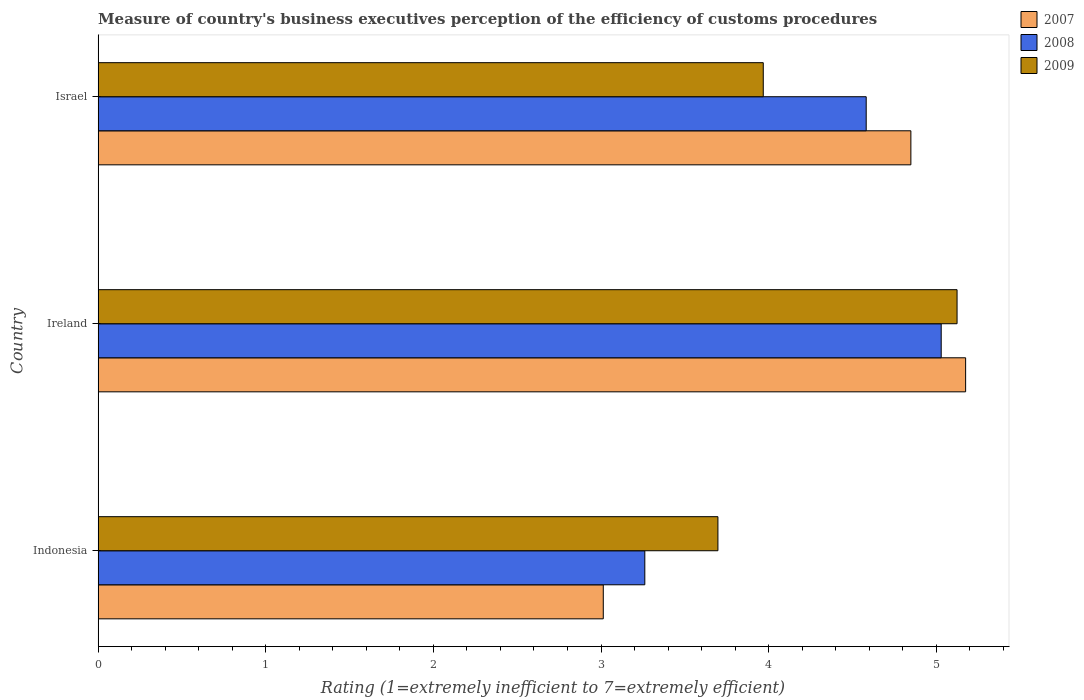How many groups of bars are there?
Your answer should be very brief. 3. How many bars are there on the 3rd tick from the top?
Ensure brevity in your answer.  3. How many bars are there on the 3rd tick from the bottom?
Your response must be concise. 3. What is the rating of the efficiency of customs procedure in 2007 in Indonesia?
Provide a succinct answer. 3.01. Across all countries, what is the maximum rating of the efficiency of customs procedure in 2007?
Give a very brief answer. 5.17. Across all countries, what is the minimum rating of the efficiency of customs procedure in 2009?
Provide a succinct answer. 3.7. In which country was the rating of the efficiency of customs procedure in 2009 maximum?
Provide a short and direct response. Ireland. In which country was the rating of the efficiency of customs procedure in 2007 minimum?
Make the answer very short. Indonesia. What is the total rating of the efficiency of customs procedure in 2007 in the graph?
Ensure brevity in your answer.  13.04. What is the difference between the rating of the efficiency of customs procedure in 2007 in Indonesia and that in Ireland?
Your answer should be very brief. -2.16. What is the difference between the rating of the efficiency of customs procedure in 2009 in Israel and the rating of the efficiency of customs procedure in 2008 in Indonesia?
Your response must be concise. 0.71. What is the average rating of the efficiency of customs procedure in 2009 per country?
Give a very brief answer. 4.26. What is the difference between the rating of the efficiency of customs procedure in 2007 and rating of the efficiency of customs procedure in 2008 in Ireland?
Your answer should be compact. 0.15. In how many countries, is the rating of the efficiency of customs procedure in 2009 greater than 2.4 ?
Offer a terse response. 3. What is the ratio of the rating of the efficiency of customs procedure in 2007 in Indonesia to that in Israel?
Offer a terse response. 0.62. Is the rating of the efficiency of customs procedure in 2008 in Indonesia less than that in Israel?
Keep it short and to the point. Yes. Is the difference between the rating of the efficiency of customs procedure in 2007 in Ireland and Israel greater than the difference between the rating of the efficiency of customs procedure in 2008 in Ireland and Israel?
Give a very brief answer. No. What is the difference between the highest and the second highest rating of the efficiency of customs procedure in 2007?
Provide a succinct answer. 0.33. What is the difference between the highest and the lowest rating of the efficiency of customs procedure in 2007?
Offer a very short reply. 2.16. In how many countries, is the rating of the efficiency of customs procedure in 2007 greater than the average rating of the efficiency of customs procedure in 2007 taken over all countries?
Your response must be concise. 2. Is the sum of the rating of the efficiency of customs procedure in 2009 in Indonesia and Israel greater than the maximum rating of the efficiency of customs procedure in 2007 across all countries?
Your answer should be compact. Yes. What does the 2nd bar from the top in Indonesia represents?
Make the answer very short. 2008. What does the 2nd bar from the bottom in Indonesia represents?
Give a very brief answer. 2008. Are all the bars in the graph horizontal?
Ensure brevity in your answer.  Yes. How many countries are there in the graph?
Provide a succinct answer. 3. How many legend labels are there?
Give a very brief answer. 3. What is the title of the graph?
Your response must be concise. Measure of country's business executives perception of the efficiency of customs procedures. Does "1971" appear as one of the legend labels in the graph?
Ensure brevity in your answer.  No. What is the label or title of the X-axis?
Offer a very short reply. Rating (1=extremely inefficient to 7=extremely efficient). What is the Rating (1=extremely inefficient to 7=extremely efficient) in 2007 in Indonesia?
Keep it short and to the point. 3.01. What is the Rating (1=extremely inefficient to 7=extremely efficient) of 2008 in Indonesia?
Your answer should be very brief. 3.26. What is the Rating (1=extremely inefficient to 7=extremely efficient) in 2009 in Indonesia?
Your response must be concise. 3.7. What is the Rating (1=extremely inefficient to 7=extremely efficient) in 2007 in Ireland?
Your response must be concise. 5.17. What is the Rating (1=extremely inefficient to 7=extremely efficient) in 2008 in Ireland?
Offer a very short reply. 5.03. What is the Rating (1=extremely inefficient to 7=extremely efficient) of 2009 in Ireland?
Make the answer very short. 5.12. What is the Rating (1=extremely inefficient to 7=extremely efficient) in 2007 in Israel?
Your response must be concise. 4.85. What is the Rating (1=extremely inefficient to 7=extremely efficient) of 2008 in Israel?
Your answer should be very brief. 4.58. What is the Rating (1=extremely inefficient to 7=extremely efficient) in 2009 in Israel?
Ensure brevity in your answer.  3.97. Across all countries, what is the maximum Rating (1=extremely inefficient to 7=extremely efficient) in 2007?
Your response must be concise. 5.17. Across all countries, what is the maximum Rating (1=extremely inefficient to 7=extremely efficient) of 2008?
Give a very brief answer. 5.03. Across all countries, what is the maximum Rating (1=extremely inefficient to 7=extremely efficient) in 2009?
Your answer should be very brief. 5.12. Across all countries, what is the minimum Rating (1=extremely inefficient to 7=extremely efficient) of 2007?
Your answer should be very brief. 3.01. Across all countries, what is the minimum Rating (1=extremely inefficient to 7=extremely efficient) in 2008?
Make the answer very short. 3.26. Across all countries, what is the minimum Rating (1=extremely inefficient to 7=extremely efficient) in 2009?
Offer a very short reply. 3.7. What is the total Rating (1=extremely inefficient to 7=extremely efficient) of 2007 in the graph?
Ensure brevity in your answer.  13.04. What is the total Rating (1=extremely inefficient to 7=extremely efficient) of 2008 in the graph?
Give a very brief answer. 12.87. What is the total Rating (1=extremely inefficient to 7=extremely efficient) of 2009 in the graph?
Your answer should be compact. 12.79. What is the difference between the Rating (1=extremely inefficient to 7=extremely efficient) of 2007 in Indonesia and that in Ireland?
Ensure brevity in your answer.  -2.16. What is the difference between the Rating (1=extremely inefficient to 7=extremely efficient) of 2008 in Indonesia and that in Ireland?
Offer a very short reply. -1.77. What is the difference between the Rating (1=extremely inefficient to 7=extremely efficient) of 2009 in Indonesia and that in Ireland?
Your answer should be very brief. -1.43. What is the difference between the Rating (1=extremely inefficient to 7=extremely efficient) of 2007 in Indonesia and that in Israel?
Provide a short and direct response. -1.83. What is the difference between the Rating (1=extremely inefficient to 7=extremely efficient) of 2008 in Indonesia and that in Israel?
Give a very brief answer. -1.32. What is the difference between the Rating (1=extremely inefficient to 7=extremely efficient) in 2009 in Indonesia and that in Israel?
Your answer should be compact. -0.27. What is the difference between the Rating (1=extremely inefficient to 7=extremely efficient) in 2007 in Ireland and that in Israel?
Make the answer very short. 0.33. What is the difference between the Rating (1=extremely inefficient to 7=extremely efficient) of 2008 in Ireland and that in Israel?
Ensure brevity in your answer.  0.45. What is the difference between the Rating (1=extremely inefficient to 7=extremely efficient) in 2009 in Ireland and that in Israel?
Offer a very short reply. 1.16. What is the difference between the Rating (1=extremely inefficient to 7=extremely efficient) in 2007 in Indonesia and the Rating (1=extremely inefficient to 7=extremely efficient) in 2008 in Ireland?
Your answer should be compact. -2.02. What is the difference between the Rating (1=extremely inefficient to 7=extremely efficient) in 2007 in Indonesia and the Rating (1=extremely inefficient to 7=extremely efficient) in 2009 in Ireland?
Ensure brevity in your answer.  -2.11. What is the difference between the Rating (1=extremely inefficient to 7=extremely efficient) in 2008 in Indonesia and the Rating (1=extremely inefficient to 7=extremely efficient) in 2009 in Ireland?
Your answer should be very brief. -1.86. What is the difference between the Rating (1=extremely inefficient to 7=extremely efficient) in 2007 in Indonesia and the Rating (1=extremely inefficient to 7=extremely efficient) in 2008 in Israel?
Your answer should be very brief. -1.57. What is the difference between the Rating (1=extremely inefficient to 7=extremely efficient) of 2007 in Indonesia and the Rating (1=extremely inefficient to 7=extremely efficient) of 2009 in Israel?
Provide a succinct answer. -0.95. What is the difference between the Rating (1=extremely inefficient to 7=extremely efficient) of 2008 in Indonesia and the Rating (1=extremely inefficient to 7=extremely efficient) of 2009 in Israel?
Make the answer very short. -0.71. What is the difference between the Rating (1=extremely inefficient to 7=extremely efficient) in 2007 in Ireland and the Rating (1=extremely inefficient to 7=extremely efficient) in 2008 in Israel?
Your answer should be compact. 0.59. What is the difference between the Rating (1=extremely inefficient to 7=extremely efficient) in 2007 in Ireland and the Rating (1=extremely inefficient to 7=extremely efficient) in 2009 in Israel?
Ensure brevity in your answer.  1.21. What is the difference between the Rating (1=extremely inefficient to 7=extremely efficient) of 2008 in Ireland and the Rating (1=extremely inefficient to 7=extremely efficient) of 2009 in Israel?
Provide a succinct answer. 1.06. What is the average Rating (1=extremely inefficient to 7=extremely efficient) of 2007 per country?
Ensure brevity in your answer.  4.35. What is the average Rating (1=extremely inefficient to 7=extremely efficient) in 2008 per country?
Keep it short and to the point. 4.29. What is the average Rating (1=extremely inefficient to 7=extremely efficient) in 2009 per country?
Your answer should be very brief. 4.26. What is the difference between the Rating (1=extremely inefficient to 7=extremely efficient) of 2007 and Rating (1=extremely inefficient to 7=extremely efficient) of 2008 in Indonesia?
Offer a terse response. -0.25. What is the difference between the Rating (1=extremely inefficient to 7=extremely efficient) of 2007 and Rating (1=extremely inefficient to 7=extremely efficient) of 2009 in Indonesia?
Make the answer very short. -0.68. What is the difference between the Rating (1=extremely inefficient to 7=extremely efficient) of 2008 and Rating (1=extremely inefficient to 7=extremely efficient) of 2009 in Indonesia?
Offer a very short reply. -0.44. What is the difference between the Rating (1=extremely inefficient to 7=extremely efficient) of 2007 and Rating (1=extremely inefficient to 7=extremely efficient) of 2008 in Ireland?
Make the answer very short. 0.15. What is the difference between the Rating (1=extremely inefficient to 7=extremely efficient) of 2007 and Rating (1=extremely inefficient to 7=extremely efficient) of 2009 in Ireland?
Give a very brief answer. 0.05. What is the difference between the Rating (1=extremely inefficient to 7=extremely efficient) of 2008 and Rating (1=extremely inefficient to 7=extremely efficient) of 2009 in Ireland?
Your response must be concise. -0.09. What is the difference between the Rating (1=extremely inefficient to 7=extremely efficient) in 2007 and Rating (1=extremely inefficient to 7=extremely efficient) in 2008 in Israel?
Your answer should be very brief. 0.27. What is the difference between the Rating (1=extremely inefficient to 7=extremely efficient) in 2007 and Rating (1=extremely inefficient to 7=extremely efficient) in 2009 in Israel?
Give a very brief answer. 0.88. What is the difference between the Rating (1=extremely inefficient to 7=extremely efficient) in 2008 and Rating (1=extremely inefficient to 7=extremely efficient) in 2009 in Israel?
Make the answer very short. 0.61. What is the ratio of the Rating (1=extremely inefficient to 7=extremely efficient) in 2007 in Indonesia to that in Ireland?
Offer a terse response. 0.58. What is the ratio of the Rating (1=extremely inefficient to 7=extremely efficient) of 2008 in Indonesia to that in Ireland?
Provide a succinct answer. 0.65. What is the ratio of the Rating (1=extremely inefficient to 7=extremely efficient) in 2009 in Indonesia to that in Ireland?
Make the answer very short. 0.72. What is the ratio of the Rating (1=extremely inefficient to 7=extremely efficient) in 2007 in Indonesia to that in Israel?
Make the answer very short. 0.62. What is the ratio of the Rating (1=extremely inefficient to 7=extremely efficient) in 2008 in Indonesia to that in Israel?
Make the answer very short. 0.71. What is the ratio of the Rating (1=extremely inefficient to 7=extremely efficient) of 2009 in Indonesia to that in Israel?
Your answer should be very brief. 0.93. What is the ratio of the Rating (1=extremely inefficient to 7=extremely efficient) in 2007 in Ireland to that in Israel?
Ensure brevity in your answer.  1.07. What is the ratio of the Rating (1=extremely inefficient to 7=extremely efficient) of 2008 in Ireland to that in Israel?
Your response must be concise. 1.1. What is the ratio of the Rating (1=extremely inefficient to 7=extremely efficient) in 2009 in Ireland to that in Israel?
Make the answer very short. 1.29. What is the difference between the highest and the second highest Rating (1=extremely inefficient to 7=extremely efficient) in 2007?
Provide a short and direct response. 0.33. What is the difference between the highest and the second highest Rating (1=extremely inefficient to 7=extremely efficient) of 2008?
Provide a succinct answer. 0.45. What is the difference between the highest and the second highest Rating (1=extremely inefficient to 7=extremely efficient) of 2009?
Keep it short and to the point. 1.16. What is the difference between the highest and the lowest Rating (1=extremely inefficient to 7=extremely efficient) of 2007?
Keep it short and to the point. 2.16. What is the difference between the highest and the lowest Rating (1=extremely inefficient to 7=extremely efficient) of 2008?
Make the answer very short. 1.77. What is the difference between the highest and the lowest Rating (1=extremely inefficient to 7=extremely efficient) in 2009?
Offer a terse response. 1.43. 